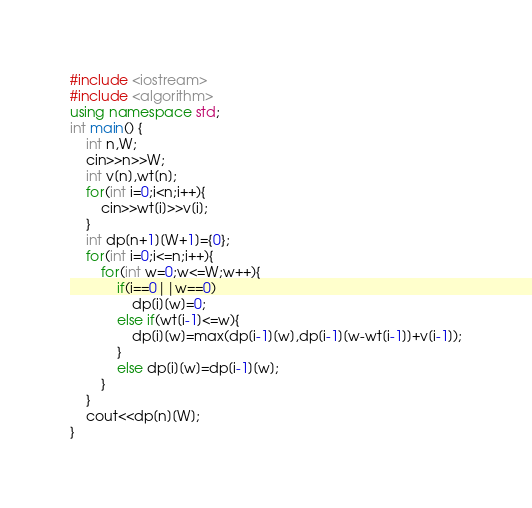<code> <loc_0><loc_0><loc_500><loc_500><_C++_>#include <iostream>
#include <algorithm>
using namespace std;
int main() {
    int n,W;
    cin>>n>>W;
    int v[n],wt[n];
    for(int i=0;i<n;i++){
        cin>>wt[i]>>v[i];
    }
    int dp[n+1][W+1]={0};
    for(int i=0;i<=n;i++){
        for(int w=0;w<=W;w++){
            if(i==0||w==0)
                dp[i][w]=0;
            else if(wt[i-1]<=w){
                dp[i][w]=max(dp[i-1][w],dp[i-1][w-wt[i-1]]+v[i-1]);
            }
            else dp[i][w]=dp[i-1][w];
        }
    }
    cout<<dp[n][W];
}</code> 